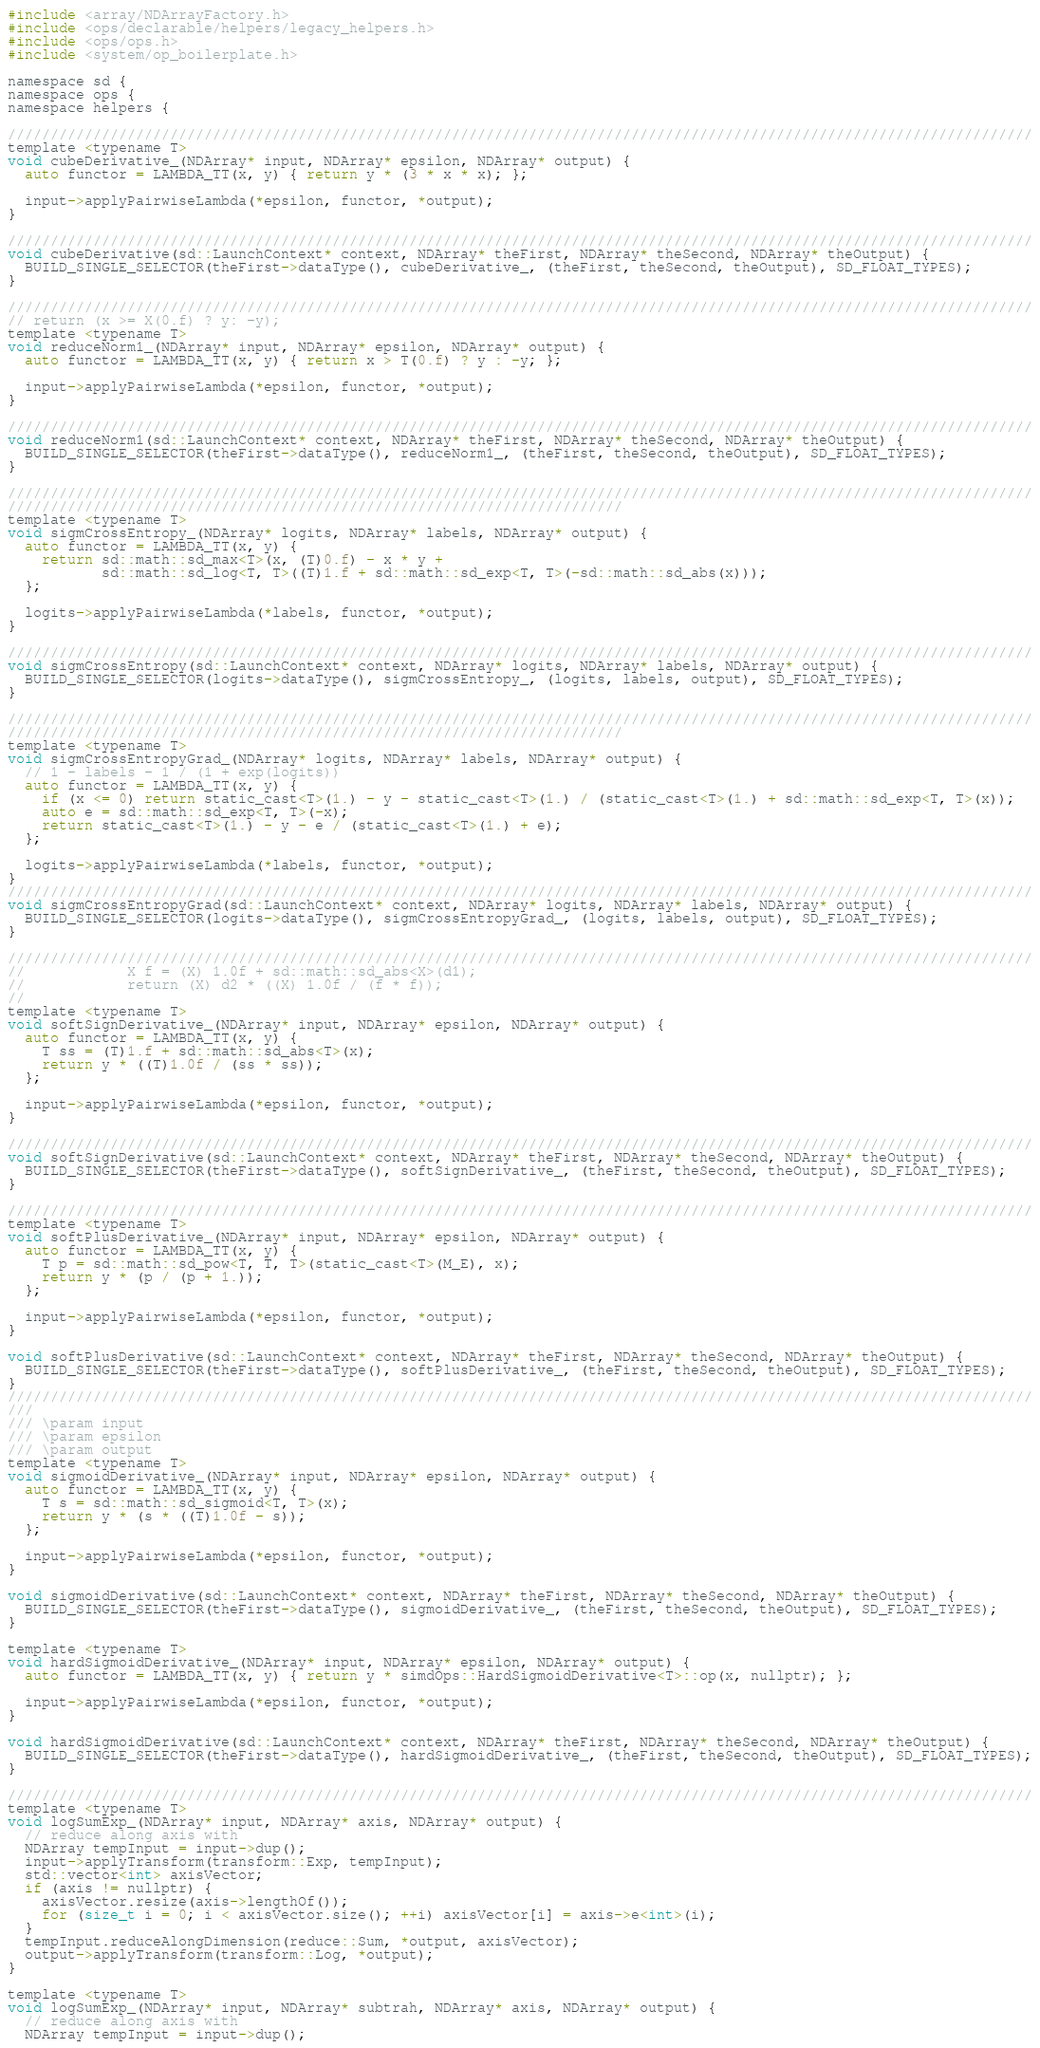Convert code to text. <code><loc_0><loc_0><loc_500><loc_500><_Cuda_>#include <array/NDArrayFactory.h>
#include <ops/declarable/helpers/legacy_helpers.h>
#include <ops/ops.h>
#include <system/op_boilerplate.h>

namespace sd {
namespace ops {
namespace helpers {

////////////////////////////////////////////////////////////////////////////////////////////////////////////////////////
template <typename T>
void cubeDerivative_(NDArray* input, NDArray* epsilon, NDArray* output) {
  auto functor = LAMBDA_TT(x, y) { return y * (3 * x * x); };

  input->applyPairwiseLambda(*epsilon, functor, *output);
}

////////////////////////////////////////////////////////////////////////////////////////////////////////////////////////
void cubeDerivative(sd::LaunchContext* context, NDArray* theFirst, NDArray* theSecond, NDArray* theOutput) {
  BUILD_SINGLE_SELECTOR(theFirst->dataType(), cubeDerivative_, (theFirst, theSecond, theOutput), SD_FLOAT_TYPES);
}

////////////////////////////////////////////////////////////////////////////////////////////////////////////////////////
// return (x >= X(0.f) ? y: -y);
template <typename T>
void reduceNorm1_(NDArray* input, NDArray* epsilon, NDArray* output) {
  auto functor = LAMBDA_TT(x, y) { return x > T(0.f) ? y : -y; };

  input->applyPairwiseLambda(*epsilon, functor, *output);
}

////////////////////////////////////////////////////////////////////////////////////////////////////////////////////////
void reduceNorm1(sd::LaunchContext* context, NDArray* theFirst, NDArray* theSecond, NDArray* theOutput) {
  BUILD_SINGLE_SELECTOR(theFirst->dataType(), reduceNorm1_, (theFirst, theSecond, theOutput), SD_FLOAT_TYPES);
}

////////////////////////////////////////////////////////////////////////////////////////////////////////////////////////
////////////////////////////////////////////////////////////////////////
template <typename T>
void sigmCrossEntropy_(NDArray* logits, NDArray* labels, NDArray* output) {
  auto functor = LAMBDA_TT(x, y) {
    return sd::math::sd_max<T>(x, (T)0.f) - x * y +
           sd::math::sd_log<T, T>((T)1.f + sd::math::sd_exp<T, T>(-sd::math::sd_abs(x)));
  };

  logits->applyPairwiseLambda(*labels, functor, *output);
}

////////////////////////////////////////////////////////////////////////////////////////////////////////////////////////
void sigmCrossEntropy(sd::LaunchContext* context, NDArray* logits, NDArray* labels, NDArray* output) {
  BUILD_SINGLE_SELECTOR(logits->dataType(), sigmCrossEntropy_, (logits, labels, output), SD_FLOAT_TYPES);
}

////////////////////////////////////////////////////////////////////////////////////////////////////////////////////////
////////////////////////////////////////////////////////////////////////
template <typename T>
void sigmCrossEntropyGrad_(NDArray* logits, NDArray* labels, NDArray* output) {
  // 1 - labels - 1 / (1 + exp(logits))
  auto functor = LAMBDA_TT(x, y) {
    if (x <= 0) return static_cast<T>(1.) - y - static_cast<T>(1.) / (static_cast<T>(1.) + sd::math::sd_exp<T, T>(x));
    auto e = sd::math::sd_exp<T, T>(-x);
    return static_cast<T>(1.) - y - e / (static_cast<T>(1.) + e);
  };

  logits->applyPairwiseLambda(*labels, functor, *output);
}
////////////////////////////////////////////////////////////////////////////////////////////////////////////////////////
void sigmCrossEntropyGrad(sd::LaunchContext* context, NDArray* logits, NDArray* labels, NDArray* output) {
  BUILD_SINGLE_SELECTOR(logits->dataType(), sigmCrossEntropyGrad_, (logits, labels, output), SD_FLOAT_TYPES);
}

////////////////////////////////////////////////////////////////////////////////////////////////////////////////////////
//            X f = (X) 1.0f + sd::math::sd_abs<X>(d1);
//            return (X) d2 * ((X) 1.0f / (f * f));
//
template <typename T>
void softSignDerivative_(NDArray* input, NDArray* epsilon, NDArray* output) {
  auto functor = LAMBDA_TT(x, y) {
    T ss = (T)1.f + sd::math::sd_abs<T>(x);
    return y * ((T)1.0f / (ss * ss));
  };

  input->applyPairwiseLambda(*epsilon, functor, *output);
}

////////////////////////////////////////////////////////////////////////////////////////////////////////////////////////
void softSignDerivative(sd::LaunchContext* context, NDArray* theFirst, NDArray* theSecond, NDArray* theOutput) {
  BUILD_SINGLE_SELECTOR(theFirst->dataType(), softSignDerivative_, (theFirst, theSecond, theOutput), SD_FLOAT_TYPES);
}

////////////////////////////////////////////////////////////////////////////////////////////////////////////////////////
template <typename T>
void softPlusDerivative_(NDArray* input, NDArray* epsilon, NDArray* output) {
  auto functor = LAMBDA_TT(x, y) {
    T p = sd::math::sd_pow<T, T, T>(static_cast<T>(M_E), x);
    return y * (p / (p + 1.));
  };

  input->applyPairwiseLambda(*epsilon, functor, *output);
}

void softPlusDerivative(sd::LaunchContext* context, NDArray* theFirst, NDArray* theSecond, NDArray* theOutput) {
  BUILD_SINGLE_SELECTOR(theFirst->dataType(), softPlusDerivative_, (theFirst, theSecond, theOutput), SD_FLOAT_TYPES);
}
////////////////////////////////////////////////////////////////////////////////////////////////////////////////////////
///
/// \param input
/// \param epsilon
/// \param output
template <typename T>
void sigmoidDerivative_(NDArray* input, NDArray* epsilon, NDArray* output) {
  auto functor = LAMBDA_TT(x, y) {
    T s = sd::math::sd_sigmoid<T, T>(x);
    return y * (s * ((T)1.0f - s));
  };

  input->applyPairwiseLambda(*epsilon, functor, *output);
}

void sigmoidDerivative(sd::LaunchContext* context, NDArray* theFirst, NDArray* theSecond, NDArray* theOutput) {
  BUILD_SINGLE_SELECTOR(theFirst->dataType(), sigmoidDerivative_, (theFirst, theSecond, theOutput), SD_FLOAT_TYPES);
}

template <typename T>
void hardSigmoidDerivative_(NDArray* input, NDArray* epsilon, NDArray* output) {
  auto functor = LAMBDA_TT(x, y) { return y * simdOps::HardSigmoidDerivative<T>::op(x, nullptr); };

  input->applyPairwiseLambda(*epsilon, functor, *output);
}

void hardSigmoidDerivative(sd::LaunchContext* context, NDArray* theFirst, NDArray* theSecond, NDArray* theOutput) {
  BUILD_SINGLE_SELECTOR(theFirst->dataType(), hardSigmoidDerivative_, (theFirst, theSecond, theOutput), SD_FLOAT_TYPES);
}

////////////////////////////////////////////////////////////////////////////////////////////////////////////////////////
template <typename T>
void logSumExp_(NDArray* input, NDArray* axis, NDArray* output) {
  // reduce along axis with
  NDArray tempInput = input->dup();
  input->applyTransform(transform::Exp, tempInput);
  std::vector<int> axisVector;
  if (axis != nullptr) {
    axisVector.resize(axis->lengthOf());
    for (size_t i = 0; i < axisVector.size(); ++i) axisVector[i] = axis->e<int>(i);
  }
  tempInput.reduceAlongDimension(reduce::Sum, *output, axisVector);
  output->applyTransform(transform::Log, *output);
}

template <typename T>
void logSumExp_(NDArray* input, NDArray* subtrah, NDArray* axis, NDArray* output) {
  // reduce along axis with
  NDArray tempInput = input->dup();</code> 